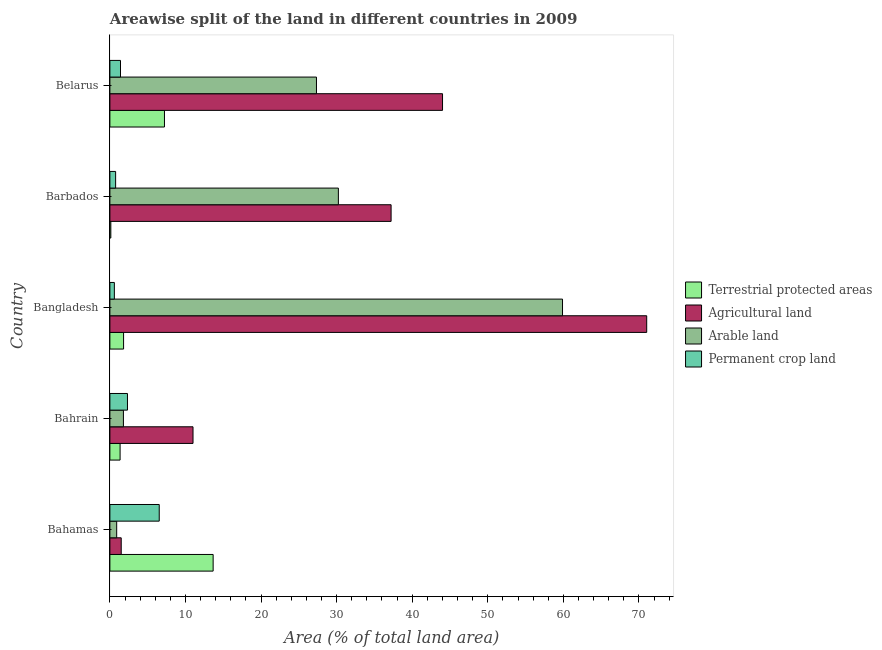Are the number of bars per tick equal to the number of legend labels?
Make the answer very short. Yes. Are the number of bars on each tick of the Y-axis equal?
Your response must be concise. Yes. How many bars are there on the 2nd tick from the top?
Give a very brief answer. 4. What is the label of the 2nd group of bars from the top?
Keep it short and to the point. Barbados. In how many cases, is the number of bars for a given country not equal to the number of legend labels?
Give a very brief answer. 0. What is the percentage of land under terrestrial protection in Bangladesh?
Provide a succinct answer. 1.81. Across all countries, what is the maximum percentage of area under permanent crop land?
Your response must be concise. 6.53. Across all countries, what is the minimum percentage of land under terrestrial protection?
Your response must be concise. 0.12. In which country was the percentage of area under permanent crop land maximum?
Give a very brief answer. Bahamas. What is the total percentage of area under agricultural land in the graph?
Make the answer very short. 164.75. What is the difference between the percentage of area under agricultural land in Bahamas and that in Barbados?
Your response must be concise. -35.71. What is the difference between the percentage of land under terrestrial protection in Bangladesh and the percentage of area under arable land in Belarus?
Give a very brief answer. -25.52. What is the average percentage of area under arable land per country?
Provide a short and direct response. 24.03. What is the difference between the percentage of area under agricultural land and percentage of area under permanent crop land in Barbados?
Ensure brevity in your answer.  36.45. In how many countries, is the percentage of area under arable land greater than 28 %?
Your answer should be compact. 2. What is the ratio of the percentage of land under terrestrial protection in Barbados to that in Belarus?
Keep it short and to the point. 0.02. Is the percentage of area under arable land in Bahrain less than that in Bangladesh?
Provide a short and direct response. Yes. Is the difference between the percentage of area under arable land in Bahrain and Barbados greater than the difference between the percentage of area under agricultural land in Bahrain and Barbados?
Provide a succinct answer. No. What is the difference between the highest and the second highest percentage of land under terrestrial protection?
Your response must be concise. 6.44. What is the difference between the highest and the lowest percentage of area under arable land?
Give a very brief answer. 58.99. Is it the case that in every country, the sum of the percentage of land under terrestrial protection and percentage of area under permanent crop land is greater than the sum of percentage of area under arable land and percentage of area under agricultural land?
Give a very brief answer. No. What does the 1st bar from the top in Bahamas represents?
Provide a short and direct response. Permanent crop land. What does the 4th bar from the bottom in Bahrain represents?
Provide a succinct answer. Permanent crop land. Is it the case that in every country, the sum of the percentage of land under terrestrial protection and percentage of area under agricultural land is greater than the percentage of area under arable land?
Keep it short and to the point. Yes. How many countries are there in the graph?
Offer a very short reply. 5. Does the graph contain grids?
Keep it short and to the point. No. What is the title of the graph?
Make the answer very short. Areawise split of the land in different countries in 2009. Does "Quality Certification" appear as one of the legend labels in the graph?
Keep it short and to the point. No. What is the label or title of the X-axis?
Offer a very short reply. Area (% of total land area). What is the Area (% of total land area) of Terrestrial protected areas in Bahamas?
Ensure brevity in your answer.  13.66. What is the Area (% of total land area) in Agricultural land in Bahamas?
Give a very brief answer. 1.5. What is the Area (% of total land area) in Arable land in Bahamas?
Offer a terse response. 0.9. What is the Area (% of total land area) in Permanent crop land in Bahamas?
Keep it short and to the point. 6.53. What is the Area (% of total land area) of Terrestrial protected areas in Bahrain?
Provide a short and direct response. 1.35. What is the Area (% of total land area) in Arable land in Bahrain?
Your answer should be very brief. 1.79. What is the Area (% of total land area) in Permanent crop land in Bahrain?
Offer a very short reply. 2.33. What is the Area (% of total land area) of Terrestrial protected areas in Bangladesh?
Your answer should be compact. 1.81. What is the Area (% of total land area) of Agricultural land in Bangladesh?
Provide a short and direct response. 71.03. What is the Area (% of total land area) of Arable land in Bangladesh?
Your response must be concise. 59.89. What is the Area (% of total land area) of Permanent crop land in Bangladesh?
Your response must be concise. 0.59. What is the Area (% of total land area) in Terrestrial protected areas in Barbados?
Give a very brief answer. 0.12. What is the Area (% of total land area) of Agricultural land in Barbados?
Your answer should be very brief. 37.21. What is the Area (% of total land area) in Arable land in Barbados?
Provide a short and direct response. 30.23. What is the Area (% of total land area) in Permanent crop land in Barbados?
Keep it short and to the point. 0.76. What is the Area (% of total land area) of Terrestrial protected areas in Belarus?
Offer a terse response. 7.22. What is the Area (% of total land area) of Agricultural land in Belarus?
Provide a short and direct response. 44.01. What is the Area (% of total land area) in Arable land in Belarus?
Your answer should be very brief. 27.33. What is the Area (% of total land area) of Permanent crop land in Belarus?
Your response must be concise. 1.4. Across all countries, what is the maximum Area (% of total land area) in Terrestrial protected areas?
Keep it short and to the point. 13.66. Across all countries, what is the maximum Area (% of total land area) in Agricultural land?
Your answer should be very brief. 71.03. Across all countries, what is the maximum Area (% of total land area) of Arable land?
Give a very brief answer. 59.89. Across all countries, what is the maximum Area (% of total land area) in Permanent crop land?
Give a very brief answer. 6.53. Across all countries, what is the minimum Area (% of total land area) in Terrestrial protected areas?
Provide a succinct answer. 0.12. Across all countries, what is the minimum Area (% of total land area) in Agricultural land?
Offer a terse response. 1.5. Across all countries, what is the minimum Area (% of total land area) of Arable land?
Offer a terse response. 0.9. Across all countries, what is the minimum Area (% of total land area) of Permanent crop land?
Provide a succinct answer. 0.59. What is the total Area (% of total land area) in Terrestrial protected areas in the graph?
Provide a short and direct response. 24.17. What is the total Area (% of total land area) of Agricultural land in the graph?
Make the answer very short. 164.75. What is the total Area (% of total land area) of Arable land in the graph?
Your response must be concise. 120.15. What is the total Area (% of total land area) of Permanent crop land in the graph?
Offer a very short reply. 11.61. What is the difference between the Area (% of total land area) of Terrestrial protected areas in Bahamas and that in Bahrain?
Provide a succinct answer. 12.31. What is the difference between the Area (% of total land area) of Agricultural land in Bahamas and that in Bahrain?
Provide a short and direct response. -9.5. What is the difference between the Area (% of total land area) in Arable land in Bahamas and that in Bahrain?
Your answer should be very brief. -0.89. What is the difference between the Area (% of total land area) in Permanent crop land in Bahamas and that in Bahrain?
Keep it short and to the point. 4.2. What is the difference between the Area (% of total land area) in Terrestrial protected areas in Bahamas and that in Bangladesh?
Make the answer very short. 11.85. What is the difference between the Area (% of total land area) in Agricultural land in Bahamas and that in Bangladesh?
Keep it short and to the point. -69.53. What is the difference between the Area (% of total land area) in Arable land in Bahamas and that in Bangladesh?
Your answer should be compact. -58.99. What is the difference between the Area (% of total land area) of Permanent crop land in Bahamas and that in Bangladesh?
Your response must be concise. 5.94. What is the difference between the Area (% of total land area) of Terrestrial protected areas in Bahamas and that in Barbados?
Offer a terse response. 13.54. What is the difference between the Area (% of total land area) in Agricultural land in Bahamas and that in Barbados?
Your answer should be compact. -35.71. What is the difference between the Area (% of total land area) of Arable land in Bahamas and that in Barbados?
Make the answer very short. -29.33. What is the difference between the Area (% of total land area) of Permanent crop land in Bahamas and that in Barbados?
Give a very brief answer. 5.77. What is the difference between the Area (% of total land area) of Terrestrial protected areas in Bahamas and that in Belarus?
Make the answer very short. 6.44. What is the difference between the Area (% of total land area) of Agricultural land in Bahamas and that in Belarus?
Offer a terse response. -42.52. What is the difference between the Area (% of total land area) in Arable land in Bahamas and that in Belarus?
Offer a terse response. -26.44. What is the difference between the Area (% of total land area) of Permanent crop land in Bahamas and that in Belarus?
Ensure brevity in your answer.  5.13. What is the difference between the Area (% of total land area) in Terrestrial protected areas in Bahrain and that in Bangladesh?
Keep it short and to the point. -0.46. What is the difference between the Area (% of total land area) in Agricultural land in Bahrain and that in Bangladesh?
Offer a terse response. -60.03. What is the difference between the Area (% of total land area) in Arable land in Bahrain and that in Bangladesh?
Provide a short and direct response. -58.1. What is the difference between the Area (% of total land area) in Permanent crop land in Bahrain and that in Bangladesh?
Your response must be concise. 1.73. What is the difference between the Area (% of total land area) of Terrestrial protected areas in Bahrain and that in Barbados?
Ensure brevity in your answer.  1.23. What is the difference between the Area (% of total land area) of Agricultural land in Bahrain and that in Barbados?
Make the answer very short. -26.21. What is the difference between the Area (% of total land area) in Arable land in Bahrain and that in Barbados?
Provide a succinct answer. -28.44. What is the difference between the Area (% of total land area) of Permanent crop land in Bahrain and that in Barbados?
Ensure brevity in your answer.  1.57. What is the difference between the Area (% of total land area) of Terrestrial protected areas in Bahrain and that in Belarus?
Offer a very short reply. -5.87. What is the difference between the Area (% of total land area) of Agricultural land in Bahrain and that in Belarus?
Make the answer very short. -33.01. What is the difference between the Area (% of total land area) in Arable land in Bahrain and that in Belarus?
Provide a succinct answer. -25.55. What is the difference between the Area (% of total land area) in Permanent crop land in Bahrain and that in Belarus?
Your answer should be very brief. 0.92. What is the difference between the Area (% of total land area) in Terrestrial protected areas in Bangladesh and that in Barbados?
Make the answer very short. 1.69. What is the difference between the Area (% of total land area) in Agricultural land in Bangladesh and that in Barbados?
Provide a short and direct response. 33.82. What is the difference between the Area (% of total land area) in Arable land in Bangladesh and that in Barbados?
Make the answer very short. 29.66. What is the difference between the Area (% of total land area) in Permanent crop land in Bangladesh and that in Barbados?
Offer a terse response. -0.17. What is the difference between the Area (% of total land area) of Terrestrial protected areas in Bangladesh and that in Belarus?
Your answer should be very brief. -5.41. What is the difference between the Area (% of total land area) of Agricultural land in Bangladesh and that in Belarus?
Provide a succinct answer. 27.02. What is the difference between the Area (% of total land area) in Arable land in Bangladesh and that in Belarus?
Your answer should be compact. 32.56. What is the difference between the Area (% of total land area) in Permanent crop land in Bangladesh and that in Belarus?
Ensure brevity in your answer.  -0.81. What is the difference between the Area (% of total land area) of Terrestrial protected areas in Barbados and that in Belarus?
Keep it short and to the point. -7.1. What is the difference between the Area (% of total land area) in Agricultural land in Barbados and that in Belarus?
Your response must be concise. -6.81. What is the difference between the Area (% of total land area) in Arable land in Barbados and that in Belarus?
Your answer should be compact. 2.9. What is the difference between the Area (% of total land area) of Permanent crop land in Barbados and that in Belarus?
Your answer should be very brief. -0.64. What is the difference between the Area (% of total land area) in Terrestrial protected areas in Bahamas and the Area (% of total land area) in Agricultural land in Bahrain?
Your answer should be compact. 2.66. What is the difference between the Area (% of total land area) of Terrestrial protected areas in Bahamas and the Area (% of total land area) of Arable land in Bahrain?
Provide a short and direct response. 11.87. What is the difference between the Area (% of total land area) of Terrestrial protected areas in Bahamas and the Area (% of total land area) of Permanent crop land in Bahrain?
Offer a very short reply. 11.34. What is the difference between the Area (% of total land area) in Agricultural land in Bahamas and the Area (% of total land area) in Arable land in Bahrain?
Ensure brevity in your answer.  -0.29. What is the difference between the Area (% of total land area) in Agricultural land in Bahamas and the Area (% of total land area) in Permanent crop land in Bahrain?
Your answer should be very brief. -0.83. What is the difference between the Area (% of total land area) of Arable land in Bahamas and the Area (% of total land area) of Permanent crop land in Bahrain?
Make the answer very short. -1.43. What is the difference between the Area (% of total land area) of Terrestrial protected areas in Bahamas and the Area (% of total land area) of Agricultural land in Bangladesh?
Keep it short and to the point. -57.37. What is the difference between the Area (% of total land area) of Terrestrial protected areas in Bahamas and the Area (% of total land area) of Arable land in Bangladesh?
Your answer should be compact. -46.23. What is the difference between the Area (% of total land area) of Terrestrial protected areas in Bahamas and the Area (% of total land area) of Permanent crop land in Bangladesh?
Your response must be concise. 13.07. What is the difference between the Area (% of total land area) in Agricultural land in Bahamas and the Area (% of total land area) in Arable land in Bangladesh?
Provide a succinct answer. -58.39. What is the difference between the Area (% of total land area) in Agricultural land in Bahamas and the Area (% of total land area) in Permanent crop land in Bangladesh?
Your answer should be compact. 0.91. What is the difference between the Area (% of total land area) of Arable land in Bahamas and the Area (% of total land area) of Permanent crop land in Bangladesh?
Provide a short and direct response. 0.31. What is the difference between the Area (% of total land area) in Terrestrial protected areas in Bahamas and the Area (% of total land area) in Agricultural land in Barbados?
Provide a succinct answer. -23.55. What is the difference between the Area (% of total land area) in Terrestrial protected areas in Bahamas and the Area (% of total land area) in Arable land in Barbados?
Offer a terse response. -16.57. What is the difference between the Area (% of total land area) of Terrestrial protected areas in Bahamas and the Area (% of total land area) of Permanent crop land in Barbados?
Give a very brief answer. 12.9. What is the difference between the Area (% of total land area) in Agricultural land in Bahamas and the Area (% of total land area) in Arable land in Barbados?
Offer a very short reply. -28.73. What is the difference between the Area (% of total land area) in Agricultural land in Bahamas and the Area (% of total land area) in Permanent crop land in Barbados?
Ensure brevity in your answer.  0.74. What is the difference between the Area (% of total land area) of Arable land in Bahamas and the Area (% of total land area) of Permanent crop land in Barbados?
Offer a very short reply. 0.14. What is the difference between the Area (% of total land area) of Terrestrial protected areas in Bahamas and the Area (% of total land area) of Agricultural land in Belarus?
Your response must be concise. -30.35. What is the difference between the Area (% of total land area) in Terrestrial protected areas in Bahamas and the Area (% of total land area) in Arable land in Belarus?
Give a very brief answer. -13.67. What is the difference between the Area (% of total land area) in Terrestrial protected areas in Bahamas and the Area (% of total land area) in Permanent crop land in Belarus?
Provide a short and direct response. 12.26. What is the difference between the Area (% of total land area) of Agricultural land in Bahamas and the Area (% of total land area) of Arable land in Belarus?
Give a very brief answer. -25.84. What is the difference between the Area (% of total land area) of Agricultural land in Bahamas and the Area (% of total land area) of Permanent crop land in Belarus?
Make the answer very short. 0.1. What is the difference between the Area (% of total land area) in Arable land in Bahamas and the Area (% of total land area) in Permanent crop land in Belarus?
Your answer should be compact. -0.5. What is the difference between the Area (% of total land area) in Terrestrial protected areas in Bahrain and the Area (% of total land area) in Agricultural land in Bangladesh?
Offer a terse response. -69.68. What is the difference between the Area (% of total land area) of Terrestrial protected areas in Bahrain and the Area (% of total land area) of Arable land in Bangladesh?
Ensure brevity in your answer.  -58.54. What is the difference between the Area (% of total land area) in Terrestrial protected areas in Bahrain and the Area (% of total land area) in Permanent crop land in Bangladesh?
Give a very brief answer. 0.76. What is the difference between the Area (% of total land area) in Agricultural land in Bahrain and the Area (% of total land area) in Arable land in Bangladesh?
Provide a short and direct response. -48.89. What is the difference between the Area (% of total land area) in Agricultural land in Bahrain and the Area (% of total land area) in Permanent crop land in Bangladesh?
Provide a succinct answer. 10.41. What is the difference between the Area (% of total land area) of Arable land in Bahrain and the Area (% of total land area) of Permanent crop land in Bangladesh?
Give a very brief answer. 1.2. What is the difference between the Area (% of total land area) in Terrestrial protected areas in Bahrain and the Area (% of total land area) in Agricultural land in Barbados?
Your answer should be very brief. -35.86. What is the difference between the Area (% of total land area) of Terrestrial protected areas in Bahrain and the Area (% of total land area) of Arable land in Barbados?
Your answer should be very brief. -28.88. What is the difference between the Area (% of total land area) in Terrestrial protected areas in Bahrain and the Area (% of total land area) in Permanent crop land in Barbados?
Your answer should be very brief. 0.59. What is the difference between the Area (% of total land area) in Agricultural land in Bahrain and the Area (% of total land area) in Arable land in Barbados?
Your response must be concise. -19.23. What is the difference between the Area (% of total land area) of Agricultural land in Bahrain and the Area (% of total land area) of Permanent crop land in Barbados?
Ensure brevity in your answer.  10.24. What is the difference between the Area (% of total land area) of Arable land in Bahrain and the Area (% of total land area) of Permanent crop land in Barbados?
Offer a terse response. 1.03. What is the difference between the Area (% of total land area) of Terrestrial protected areas in Bahrain and the Area (% of total land area) of Agricultural land in Belarus?
Offer a very short reply. -42.66. What is the difference between the Area (% of total land area) in Terrestrial protected areas in Bahrain and the Area (% of total land area) in Arable land in Belarus?
Give a very brief answer. -25.98. What is the difference between the Area (% of total land area) in Terrestrial protected areas in Bahrain and the Area (% of total land area) in Permanent crop land in Belarus?
Make the answer very short. -0.05. What is the difference between the Area (% of total land area) in Agricultural land in Bahrain and the Area (% of total land area) in Arable land in Belarus?
Your answer should be very brief. -16.33. What is the difference between the Area (% of total land area) of Agricultural land in Bahrain and the Area (% of total land area) of Permanent crop land in Belarus?
Give a very brief answer. 9.6. What is the difference between the Area (% of total land area) of Arable land in Bahrain and the Area (% of total land area) of Permanent crop land in Belarus?
Provide a succinct answer. 0.39. What is the difference between the Area (% of total land area) in Terrestrial protected areas in Bangladesh and the Area (% of total land area) in Agricultural land in Barbados?
Give a very brief answer. -35.4. What is the difference between the Area (% of total land area) of Terrestrial protected areas in Bangladesh and the Area (% of total land area) of Arable land in Barbados?
Your answer should be very brief. -28.42. What is the difference between the Area (% of total land area) of Terrestrial protected areas in Bangladesh and the Area (% of total land area) of Permanent crop land in Barbados?
Give a very brief answer. 1.05. What is the difference between the Area (% of total land area) of Agricultural land in Bangladesh and the Area (% of total land area) of Arable land in Barbados?
Offer a terse response. 40.8. What is the difference between the Area (% of total land area) of Agricultural land in Bangladesh and the Area (% of total land area) of Permanent crop land in Barbados?
Ensure brevity in your answer.  70.27. What is the difference between the Area (% of total land area) in Arable land in Bangladesh and the Area (% of total land area) in Permanent crop land in Barbados?
Provide a short and direct response. 59.13. What is the difference between the Area (% of total land area) in Terrestrial protected areas in Bangladesh and the Area (% of total land area) in Agricultural land in Belarus?
Ensure brevity in your answer.  -42.2. What is the difference between the Area (% of total land area) in Terrestrial protected areas in Bangladesh and the Area (% of total land area) in Arable land in Belarus?
Offer a very short reply. -25.52. What is the difference between the Area (% of total land area) of Terrestrial protected areas in Bangladesh and the Area (% of total land area) of Permanent crop land in Belarus?
Your response must be concise. 0.41. What is the difference between the Area (% of total land area) in Agricultural land in Bangladesh and the Area (% of total land area) in Arable land in Belarus?
Your answer should be very brief. 43.7. What is the difference between the Area (% of total land area) in Agricultural land in Bangladesh and the Area (% of total land area) in Permanent crop land in Belarus?
Ensure brevity in your answer.  69.63. What is the difference between the Area (% of total land area) of Arable land in Bangladesh and the Area (% of total land area) of Permanent crop land in Belarus?
Provide a succinct answer. 58.49. What is the difference between the Area (% of total land area) of Terrestrial protected areas in Barbados and the Area (% of total land area) of Agricultural land in Belarus?
Offer a terse response. -43.89. What is the difference between the Area (% of total land area) of Terrestrial protected areas in Barbados and the Area (% of total land area) of Arable land in Belarus?
Provide a short and direct response. -27.21. What is the difference between the Area (% of total land area) of Terrestrial protected areas in Barbados and the Area (% of total land area) of Permanent crop land in Belarus?
Ensure brevity in your answer.  -1.28. What is the difference between the Area (% of total land area) of Agricultural land in Barbados and the Area (% of total land area) of Arable land in Belarus?
Ensure brevity in your answer.  9.87. What is the difference between the Area (% of total land area) in Agricultural land in Barbados and the Area (% of total land area) in Permanent crop land in Belarus?
Make the answer very short. 35.81. What is the difference between the Area (% of total land area) in Arable land in Barbados and the Area (% of total land area) in Permanent crop land in Belarus?
Offer a terse response. 28.83. What is the average Area (% of total land area) of Terrestrial protected areas per country?
Offer a very short reply. 4.83. What is the average Area (% of total land area) in Agricultural land per country?
Make the answer very short. 32.95. What is the average Area (% of total land area) of Arable land per country?
Provide a succinct answer. 24.03. What is the average Area (% of total land area) of Permanent crop land per country?
Offer a terse response. 2.32. What is the difference between the Area (% of total land area) of Terrestrial protected areas and Area (% of total land area) of Agricultural land in Bahamas?
Your answer should be compact. 12.16. What is the difference between the Area (% of total land area) of Terrestrial protected areas and Area (% of total land area) of Arable land in Bahamas?
Offer a terse response. 12.76. What is the difference between the Area (% of total land area) in Terrestrial protected areas and Area (% of total land area) in Permanent crop land in Bahamas?
Make the answer very short. 7.13. What is the difference between the Area (% of total land area) of Agricultural land and Area (% of total land area) of Arable land in Bahamas?
Make the answer very short. 0.6. What is the difference between the Area (% of total land area) of Agricultural land and Area (% of total land area) of Permanent crop land in Bahamas?
Ensure brevity in your answer.  -5.03. What is the difference between the Area (% of total land area) in Arable land and Area (% of total land area) in Permanent crop land in Bahamas?
Ensure brevity in your answer.  -5.63. What is the difference between the Area (% of total land area) of Terrestrial protected areas and Area (% of total land area) of Agricultural land in Bahrain?
Your answer should be compact. -9.65. What is the difference between the Area (% of total land area) of Terrestrial protected areas and Area (% of total land area) of Arable land in Bahrain?
Give a very brief answer. -0.44. What is the difference between the Area (% of total land area) in Terrestrial protected areas and Area (% of total land area) in Permanent crop land in Bahrain?
Give a very brief answer. -0.98. What is the difference between the Area (% of total land area) of Agricultural land and Area (% of total land area) of Arable land in Bahrain?
Give a very brief answer. 9.21. What is the difference between the Area (% of total land area) of Agricultural land and Area (% of total land area) of Permanent crop land in Bahrain?
Provide a succinct answer. 8.67. What is the difference between the Area (% of total land area) in Arable land and Area (% of total land area) in Permanent crop land in Bahrain?
Keep it short and to the point. -0.54. What is the difference between the Area (% of total land area) in Terrestrial protected areas and Area (% of total land area) in Agricultural land in Bangladesh?
Ensure brevity in your answer.  -69.22. What is the difference between the Area (% of total land area) in Terrestrial protected areas and Area (% of total land area) in Arable land in Bangladesh?
Keep it short and to the point. -58.08. What is the difference between the Area (% of total land area) of Terrestrial protected areas and Area (% of total land area) of Permanent crop land in Bangladesh?
Give a very brief answer. 1.22. What is the difference between the Area (% of total land area) in Agricultural land and Area (% of total land area) in Arable land in Bangladesh?
Your answer should be very brief. 11.14. What is the difference between the Area (% of total land area) in Agricultural land and Area (% of total land area) in Permanent crop land in Bangladesh?
Ensure brevity in your answer.  70.44. What is the difference between the Area (% of total land area) of Arable land and Area (% of total land area) of Permanent crop land in Bangladesh?
Ensure brevity in your answer.  59.3. What is the difference between the Area (% of total land area) of Terrestrial protected areas and Area (% of total land area) of Agricultural land in Barbados?
Your answer should be compact. -37.09. What is the difference between the Area (% of total land area) of Terrestrial protected areas and Area (% of total land area) of Arable land in Barbados?
Ensure brevity in your answer.  -30.11. What is the difference between the Area (% of total land area) in Terrestrial protected areas and Area (% of total land area) in Permanent crop land in Barbados?
Offer a terse response. -0.64. What is the difference between the Area (% of total land area) in Agricultural land and Area (% of total land area) in Arable land in Barbados?
Provide a succinct answer. 6.98. What is the difference between the Area (% of total land area) of Agricultural land and Area (% of total land area) of Permanent crop land in Barbados?
Your answer should be compact. 36.45. What is the difference between the Area (% of total land area) in Arable land and Area (% of total land area) in Permanent crop land in Barbados?
Your answer should be very brief. 29.47. What is the difference between the Area (% of total land area) of Terrestrial protected areas and Area (% of total land area) of Agricultural land in Belarus?
Provide a succinct answer. -36.79. What is the difference between the Area (% of total land area) in Terrestrial protected areas and Area (% of total land area) in Arable land in Belarus?
Your answer should be compact. -20.11. What is the difference between the Area (% of total land area) of Terrestrial protected areas and Area (% of total land area) of Permanent crop land in Belarus?
Provide a succinct answer. 5.82. What is the difference between the Area (% of total land area) of Agricultural land and Area (% of total land area) of Arable land in Belarus?
Your answer should be very brief. 16.68. What is the difference between the Area (% of total land area) of Agricultural land and Area (% of total land area) of Permanent crop land in Belarus?
Provide a short and direct response. 42.61. What is the difference between the Area (% of total land area) of Arable land and Area (% of total land area) of Permanent crop land in Belarus?
Make the answer very short. 25.93. What is the ratio of the Area (% of total land area) in Terrestrial protected areas in Bahamas to that in Bahrain?
Ensure brevity in your answer.  10.12. What is the ratio of the Area (% of total land area) in Agricultural land in Bahamas to that in Bahrain?
Your answer should be compact. 0.14. What is the ratio of the Area (% of total land area) in Arable land in Bahamas to that in Bahrain?
Make the answer very short. 0.5. What is the ratio of the Area (% of total land area) of Permanent crop land in Bahamas to that in Bahrain?
Give a very brief answer. 2.81. What is the ratio of the Area (% of total land area) in Terrestrial protected areas in Bahamas to that in Bangladesh?
Offer a very short reply. 7.55. What is the ratio of the Area (% of total land area) in Agricultural land in Bahamas to that in Bangladesh?
Provide a short and direct response. 0.02. What is the ratio of the Area (% of total land area) of Arable land in Bahamas to that in Bangladesh?
Give a very brief answer. 0.01. What is the ratio of the Area (% of total land area) of Permanent crop land in Bahamas to that in Bangladesh?
Keep it short and to the point. 11.04. What is the ratio of the Area (% of total land area) in Terrestrial protected areas in Bahamas to that in Barbados?
Ensure brevity in your answer.  110.06. What is the ratio of the Area (% of total land area) in Agricultural land in Bahamas to that in Barbados?
Provide a succinct answer. 0.04. What is the ratio of the Area (% of total land area) in Arable land in Bahamas to that in Barbados?
Ensure brevity in your answer.  0.03. What is the ratio of the Area (% of total land area) of Permanent crop land in Bahamas to that in Barbados?
Make the answer very short. 8.6. What is the ratio of the Area (% of total land area) in Terrestrial protected areas in Bahamas to that in Belarus?
Give a very brief answer. 1.89. What is the ratio of the Area (% of total land area) in Agricultural land in Bahamas to that in Belarus?
Ensure brevity in your answer.  0.03. What is the ratio of the Area (% of total land area) of Arable land in Bahamas to that in Belarus?
Offer a terse response. 0.03. What is the ratio of the Area (% of total land area) in Permanent crop land in Bahamas to that in Belarus?
Provide a succinct answer. 4.65. What is the ratio of the Area (% of total land area) of Terrestrial protected areas in Bahrain to that in Bangladesh?
Provide a short and direct response. 0.75. What is the ratio of the Area (% of total land area) of Agricultural land in Bahrain to that in Bangladesh?
Your response must be concise. 0.15. What is the ratio of the Area (% of total land area) of Arable land in Bahrain to that in Bangladesh?
Your answer should be very brief. 0.03. What is the ratio of the Area (% of total land area) in Permanent crop land in Bahrain to that in Bangladesh?
Your answer should be compact. 3.93. What is the ratio of the Area (% of total land area) of Terrestrial protected areas in Bahrain to that in Barbados?
Make the answer very short. 10.87. What is the ratio of the Area (% of total land area) of Agricultural land in Bahrain to that in Barbados?
Keep it short and to the point. 0.3. What is the ratio of the Area (% of total land area) of Arable land in Bahrain to that in Barbados?
Keep it short and to the point. 0.06. What is the ratio of the Area (% of total land area) in Permanent crop land in Bahrain to that in Barbados?
Keep it short and to the point. 3.06. What is the ratio of the Area (% of total land area) in Terrestrial protected areas in Bahrain to that in Belarus?
Ensure brevity in your answer.  0.19. What is the ratio of the Area (% of total land area) in Agricultural land in Bahrain to that in Belarus?
Provide a short and direct response. 0.25. What is the ratio of the Area (% of total land area) of Arable land in Bahrain to that in Belarus?
Ensure brevity in your answer.  0.07. What is the ratio of the Area (% of total land area) of Permanent crop land in Bahrain to that in Belarus?
Offer a very short reply. 1.66. What is the ratio of the Area (% of total land area) of Terrestrial protected areas in Bangladesh to that in Barbados?
Your response must be concise. 14.58. What is the ratio of the Area (% of total land area) in Agricultural land in Bangladesh to that in Barbados?
Offer a terse response. 1.91. What is the ratio of the Area (% of total land area) in Arable land in Bangladesh to that in Barbados?
Keep it short and to the point. 1.98. What is the ratio of the Area (% of total land area) in Permanent crop land in Bangladesh to that in Barbados?
Ensure brevity in your answer.  0.78. What is the ratio of the Area (% of total land area) in Terrestrial protected areas in Bangladesh to that in Belarus?
Make the answer very short. 0.25. What is the ratio of the Area (% of total land area) of Agricultural land in Bangladesh to that in Belarus?
Give a very brief answer. 1.61. What is the ratio of the Area (% of total land area) of Arable land in Bangladesh to that in Belarus?
Offer a very short reply. 2.19. What is the ratio of the Area (% of total land area) in Permanent crop land in Bangladesh to that in Belarus?
Your response must be concise. 0.42. What is the ratio of the Area (% of total land area) in Terrestrial protected areas in Barbados to that in Belarus?
Your answer should be compact. 0.02. What is the ratio of the Area (% of total land area) of Agricultural land in Barbados to that in Belarus?
Offer a terse response. 0.85. What is the ratio of the Area (% of total land area) of Arable land in Barbados to that in Belarus?
Your answer should be compact. 1.11. What is the ratio of the Area (% of total land area) of Permanent crop land in Barbados to that in Belarus?
Give a very brief answer. 0.54. What is the difference between the highest and the second highest Area (% of total land area) in Terrestrial protected areas?
Keep it short and to the point. 6.44. What is the difference between the highest and the second highest Area (% of total land area) of Agricultural land?
Your response must be concise. 27.02. What is the difference between the highest and the second highest Area (% of total land area) in Arable land?
Your answer should be compact. 29.66. What is the difference between the highest and the second highest Area (% of total land area) in Permanent crop land?
Your response must be concise. 4.2. What is the difference between the highest and the lowest Area (% of total land area) of Terrestrial protected areas?
Provide a short and direct response. 13.54. What is the difference between the highest and the lowest Area (% of total land area) of Agricultural land?
Offer a terse response. 69.53. What is the difference between the highest and the lowest Area (% of total land area) of Arable land?
Offer a very short reply. 58.99. What is the difference between the highest and the lowest Area (% of total land area) in Permanent crop land?
Your answer should be compact. 5.94. 